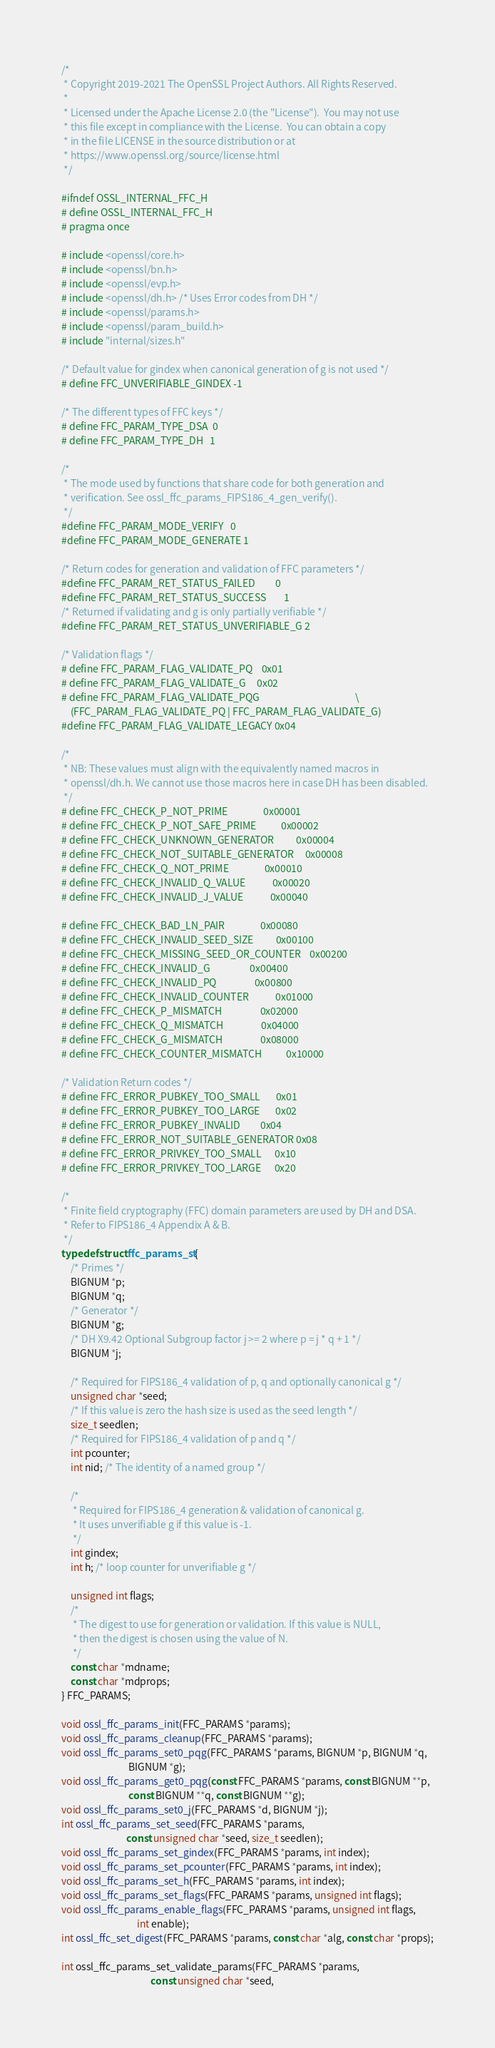Convert code to text. <code><loc_0><loc_0><loc_500><loc_500><_C_>/*
 * Copyright 2019-2021 The OpenSSL Project Authors. All Rights Reserved.
 *
 * Licensed under the Apache License 2.0 (the "License").  You may not use
 * this file except in compliance with the License.  You can obtain a copy
 * in the file LICENSE in the source distribution or at
 * https://www.openssl.org/source/license.html
 */

#ifndef OSSL_INTERNAL_FFC_H
# define OSSL_INTERNAL_FFC_H
# pragma once

# include <openssl/core.h>
# include <openssl/bn.h>
# include <openssl/evp.h>
# include <openssl/dh.h> /* Uses Error codes from DH */
# include <openssl/params.h>
# include <openssl/param_build.h>
# include "internal/sizes.h"

/* Default value for gindex when canonical generation of g is not used */
# define FFC_UNVERIFIABLE_GINDEX -1

/* The different types of FFC keys */
# define FFC_PARAM_TYPE_DSA  0
# define FFC_PARAM_TYPE_DH   1

/*
 * The mode used by functions that share code for both generation and
 * verification. See ossl_ffc_params_FIPS186_4_gen_verify().
 */
#define FFC_PARAM_MODE_VERIFY   0
#define FFC_PARAM_MODE_GENERATE 1

/* Return codes for generation and validation of FFC parameters */
#define FFC_PARAM_RET_STATUS_FAILED         0
#define FFC_PARAM_RET_STATUS_SUCCESS        1
/* Returned if validating and g is only partially verifiable */
#define FFC_PARAM_RET_STATUS_UNVERIFIABLE_G 2

/* Validation flags */
# define FFC_PARAM_FLAG_VALIDATE_PQ    0x01
# define FFC_PARAM_FLAG_VALIDATE_G     0x02
# define FFC_PARAM_FLAG_VALIDATE_PQG                                           \
    (FFC_PARAM_FLAG_VALIDATE_PQ | FFC_PARAM_FLAG_VALIDATE_G)
#define FFC_PARAM_FLAG_VALIDATE_LEGACY 0x04

/*
 * NB: These values must align with the equivalently named macros in
 * openssl/dh.h. We cannot use those macros here in case DH has been disabled.
 */
# define FFC_CHECK_P_NOT_PRIME                0x00001
# define FFC_CHECK_P_NOT_SAFE_PRIME           0x00002
# define FFC_CHECK_UNKNOWN_GENERATOR          0x00004
# define FFC_CHECK_NOT_SUITABLE_GENERATOR     0x00008
# define FFC_CHECK_Q_NOT_PRIME                0x00010
# define FFC_CHECK_INVALID_Q_VALUE            0x00020
# define FFC_CHECK_INVALID_J_VALUE            0x00040

# define FFC_CHECK_BAD_LN_PAIR                0x00080
# define FFC_CHECK_INVALID_SEED_SIZE          0x00100
# define FFC_CHECK_MISSING_SEED_OR_COUNTER    0x00200
# define FFC_CHECK_INVALID_G                  0x00400
# define FFC_CHECK_INVALID_PQ                 0x00800
# define FFC_CHECK_INVALID_COUNTER            0x01000
# define FFC_CHECK_P_MISMATCH                 0x02000
# define FFC_CHECK_Q_MISMATCH                 0x04000
# define FFC_CHECK_G_MISMATCH                 0x08000
# define FFC_CHECK_COUNTER_MISMATCH           0x10000

/* Validation Return codes */
# define FFC_ERROR_PUBKEY_TOO_SMALL       0x01
# define FFC_ERROR_PUBKEY_TOO_LARGE       0x02
# define FFC_ERROR_PUBKEY_INVALID         0x04
# define FFC_ERROR_NOT_SUITABLE_GENERATOR 0x08
# define FFC_ERROR_PRIVKEY_TOO_SMALL      0x10
# define FFC_ERROR_PRIVKEY_TOO_LARGE      0x20

/*
 * Finite field cryptography (FFC) domain parameters are used by DH and DSA.
 * Refer to FIPS186_4 Appendix A & B.
 */
typedef struct ffc_params_st {
    /* Primes */
    BIGNUM *p;
    BIGNUM *q;
    /* Generator */
    BIGNUM *g;
    /* DH X9.42 Optional Subgroup factor j >= 2 where p = j * q + 1 */
    BIGNUM *j;

    /* Required for FIPS186_4 validation of p, q and optionally canonical g */
    unsigned char *seed;
    /* If this value is zero the hash size is used as the seed length */
    size_t seedlen;
    /* Required for FIPS186_4 validation of p and q */
    int pcounter;
    int nid; /* The identity of a named group */

    /*
     * Required for FIPS186_4 generation & validation of canonical g.
     * It uses unverifiable g if this value is -1.
     */
    int gindex;
    int h; /* loop counter for unverifiable g */

    unsigned int flags;
    /*
     * The digest to use for generation or validation. If this value is NULL,
     * then the digest is chosen using the value of N.
     */
    const char *mdname;
    const char *mdprops;
} FFC_PARAMS;

void ossl_ffc_params_init(FFC_PARAMS *params);
void ossl_ffc_params_cleanup(FFC_PARAMS *params);
void ossl_ffc_params_set0_pqg(FFC_PARAMS *params, BIGNUM *p, BIGNUM *q,
                              BIGNUM *g);
void ossl_ffc_params_get0_pqg(const FFC_PARAMS *params, const BIGNUM **p,
                              const BIGNUM **q, const BIGNUM **g);
void ossl_ffc_params_set0_j(FFC_PARAMS *d, BIGNUM *j);
int ossl_ffc_params_set_seed(FFC_PARAMS *params,
                             const unsigned char *seed, size_t seedlen);
void ossl_ffc_params_set_gindex(FFC_PARAMS *params, int index);
void ossl_ffc_params_set_pcounter(FFC_PARAMS *params, int index);
void ossl_ffc_params_set_h(FFC_PARAMS *params, int index);
void ossl_ffc_params_set_flags(FFC_PARAMS *params, unsigned int flags);
void ossl_ffc_params_enable_flags(FFC_PARAMS *params, unsigned int flags,
                                  int enable);
int ossl_ffc_set_digest(FFC_PARAMS *params, const char *alg, const char *props);

int ossl_ffc_params_set_validate_params(FFC_PARAMS *params,
                                        const unsigned char *seed,</code> 